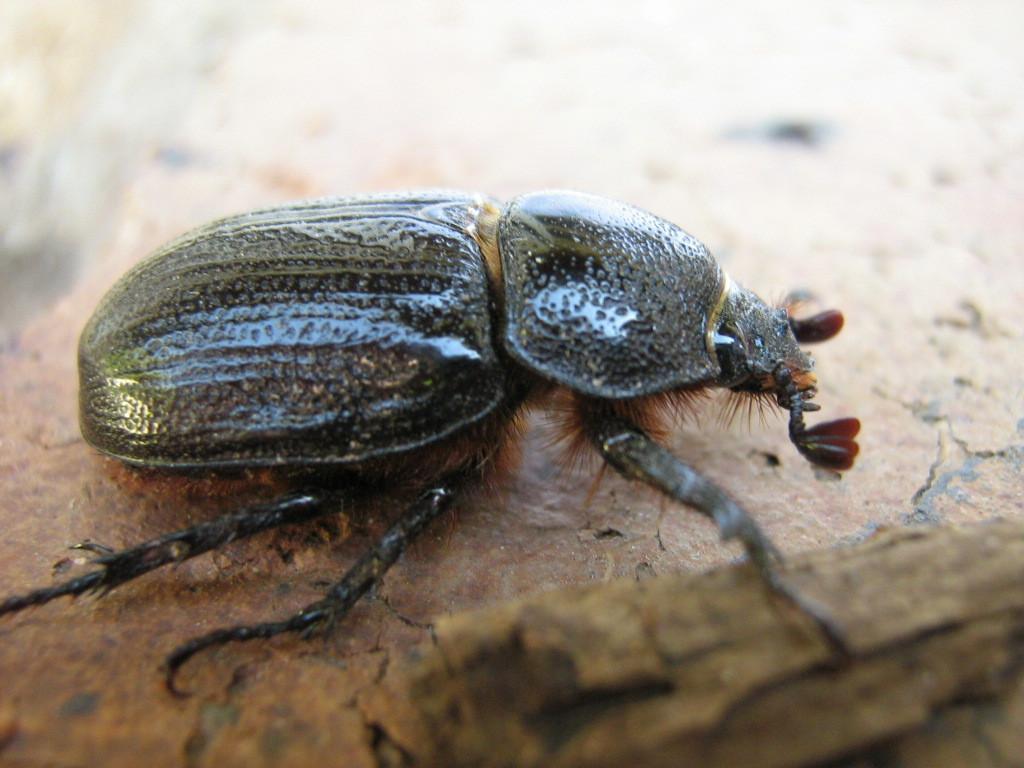How would you summarize this image in a sentence or two? In this image we can see an insect on the surface. 